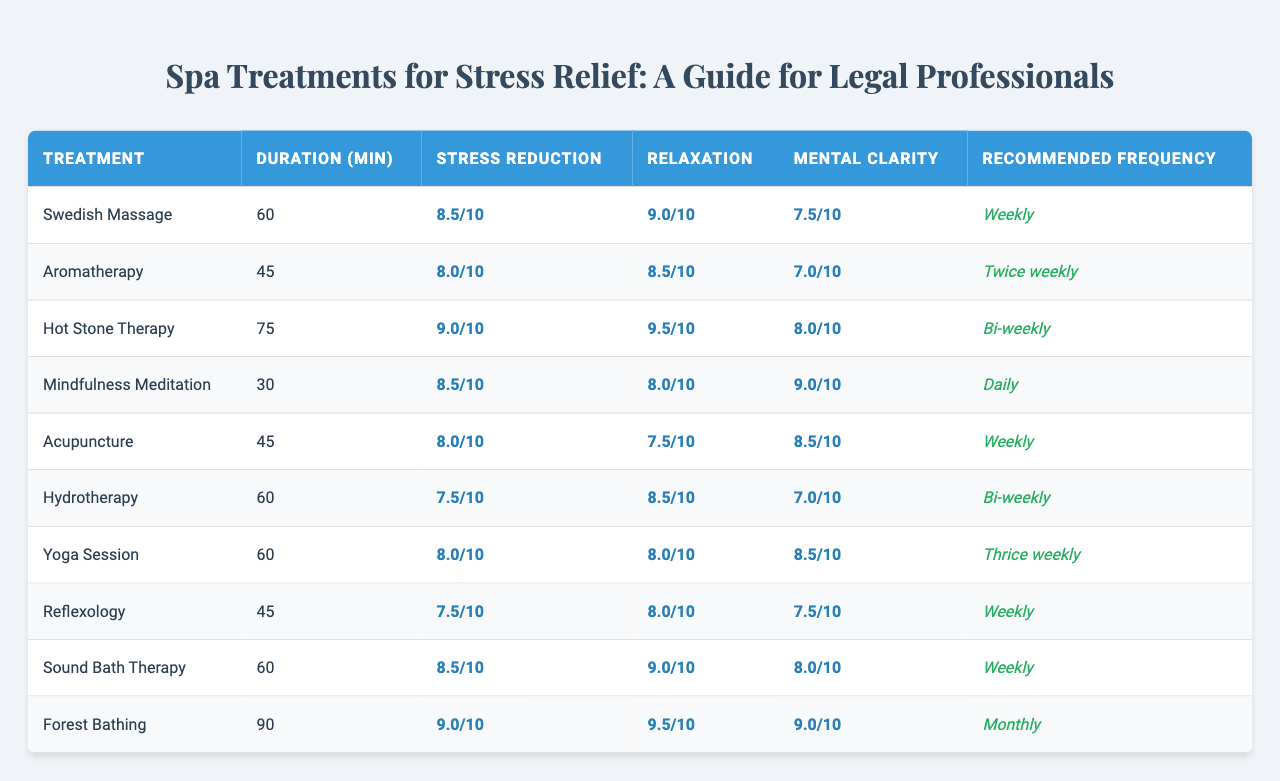What is the stress reduction score for Hot Stone Therapy? The table indicates that the stress reduction score for Hot Stone Therapy is listed in the corresponding row under the Stress Reduction column. Referring to that row shows the score is 9.0.
Answer: 9.0 Which treatment is recommended to be done daily? By examining the column for the Recommended Frequency, we see that Mindfulness Meditation has "Daily" listed as its frequency.
Answer: Mindfulness Meditation What is the duration of the Swedish Massage treatment? Looking at the Duration column for the Swedish Massage, we find it is noted as 60 minutes.
Answer: 60 minutes Is Yoga Session suitable for legal professionals? The table specifies suitability in the Suitable for Legal Professionals column. For Yoga Session, it indicates true.
Answer: Yes What is the average mental clarity improvement score for all treatments? To find the average, we first sum the mental clarity improvement scores (7.5 + 7.0 + 8.0 + 9.0 + 8.5 + 7.0 + 8.5 + 7.5 + 8.0 + 9.0) which equals 81.5. There are 10 treatments, so the average is 81.5 divided by 10, resulting in 8.15.
Answer: 8.15 Which treatment has the highest relaxation score? By comparing the Relaxation scores across all treatments, Hot Stone Therapy has the highest score at 9.5.
Answer: Hot Stone Therapy How many treatments are recommended once a week? The table lists treatments with a recommended frequency of "Weekly." They are Swedish Massage, Acupuncture, Reflexology, and Sound Bath Therapy, totaling four treatments.
Answer: 4 What is the difference in stress reduction scores between Forest Bathing and Hydrotherapy? Forest Bathing has a stress reduction score of 9.0 and Hydrotherapy has a score of 7.5. The difference is calculated as 9.0 - 7.5 = 1.5.
Answer: 1.5 Is the duration of Aromatherapy treatment longer than Reflexology treatment? Aromatherapy has a duration of 45 minutes and Reflexology also has a duration of 45 minutes. Since they are equal, the answer is no.
Answer: No What is the frequency recommended for the treatment that improves mental clarity the most? Looking at the Mental Clarity Improvement scores, Mindfulness Meditation improves the most with a score of 9.0. The table shows it is recommended daily.
Answer: Daily 